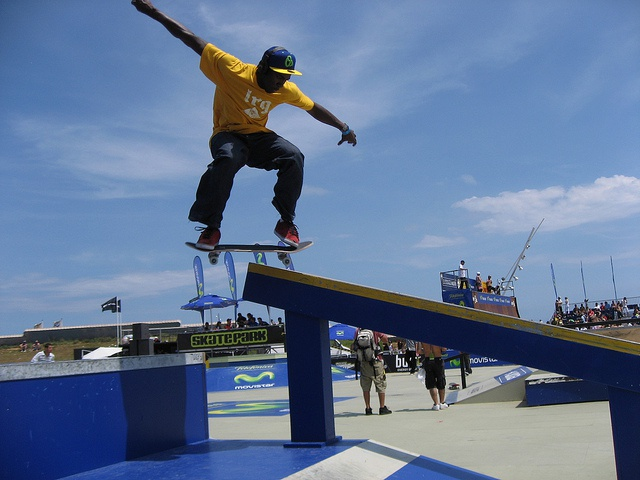Describe the objects in this image and their specific colors. I can see people in blue, black, maroon, and gray tones, people in blue, black, gray, and darkgray tones, people in blue, black, maroon, darkgray, and gray tones, skateboard in blue, black, gray, and darkgray tones, and backpack in blue, black, gray, darkgray, and lightgray tones in this image. 